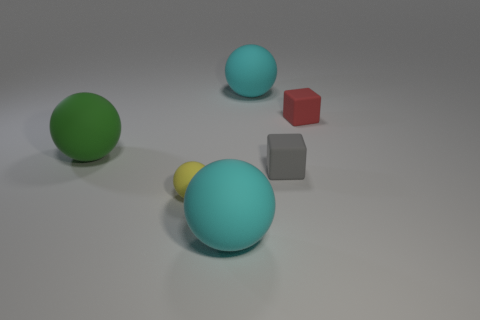There is a large matte thing that is to the left of the small rubber ball; is it the same color as the large object that is in front of the yellow sphere?
Offer a terse response. No. There is a cyan ball in front of the big thing to the right of the big cyan rubber object that is in front of the tiny gray rubber object; what is it made of?
Ensure brevity in your answer.  Rubber. Are there more large cyan balls than gray matte cylinders?
Offer a very short reply. Yes. Is there any other thing that has the same color as the tiny sphere?
Offer a terse response. No. The green object that is the same material as the tiny gray cube is what size?
Provide a succinct answer. Large. What material is the large green ball?
Offer a terse response. Rubber. What number of matte objects have the same size as the gray matte block?
Provide a short and direct response. 2. Is there another tiny gray rubber object of the same shape as the tiny gray matte object?
Your response must be concise. No. There is a matte ball that is the same size as the gray cube; what color is it?
Your answer should be very brief. Yellow. There is a large ball left of the big cyan rubber object that is in front of the yellow matte thing; what color is it?
Your response must be concise. Green. 